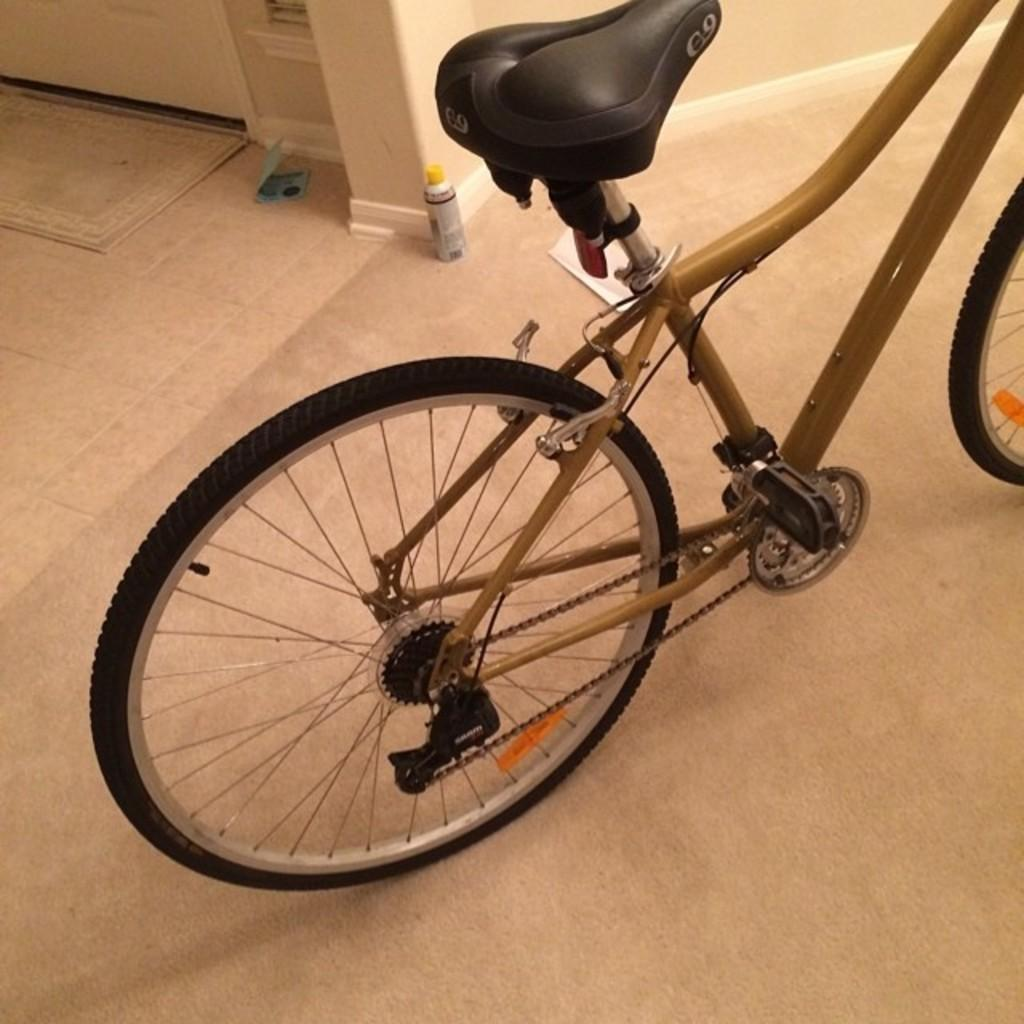What object is placed on the floor in the image? There is a cycle on the floor in the image. What can be seen in the background of the image? There is a mat, a door, and a wall in the background of the image. What type of wire is being used to work on the hour in the image? There is no wire or hour present in the image; it only features a cycle on the floor and objects in the background. 